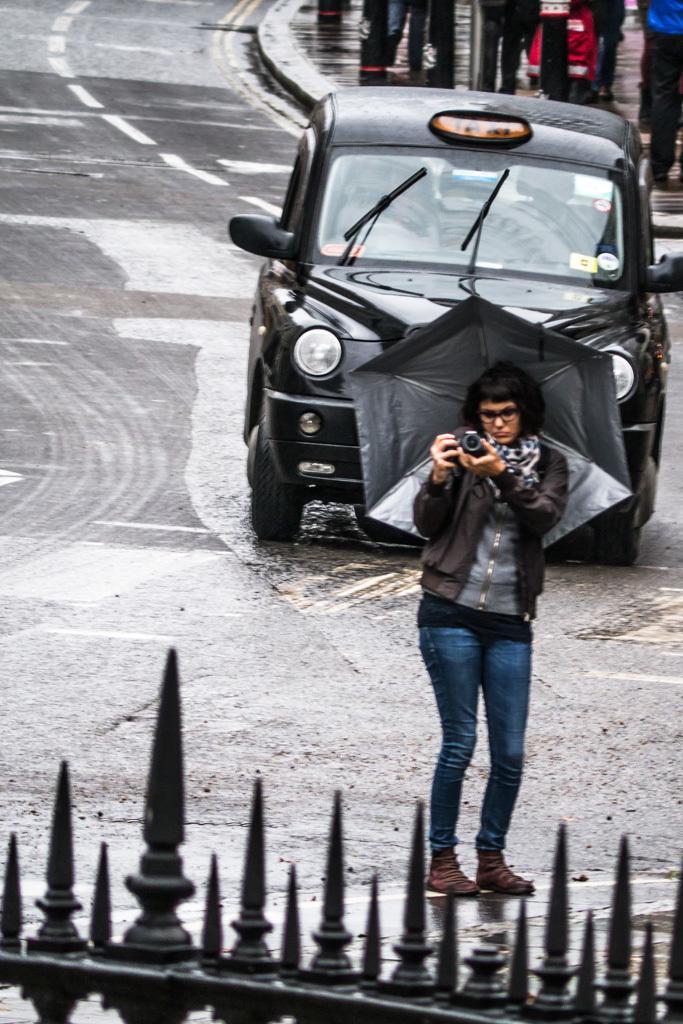Describe this image in one or two sentences. At the bottom there is a railing, behind the railing there is a woman standing on a road holding camera in her hand and wearing an umbrella, in the background there is a car and people walking on a footpath. 